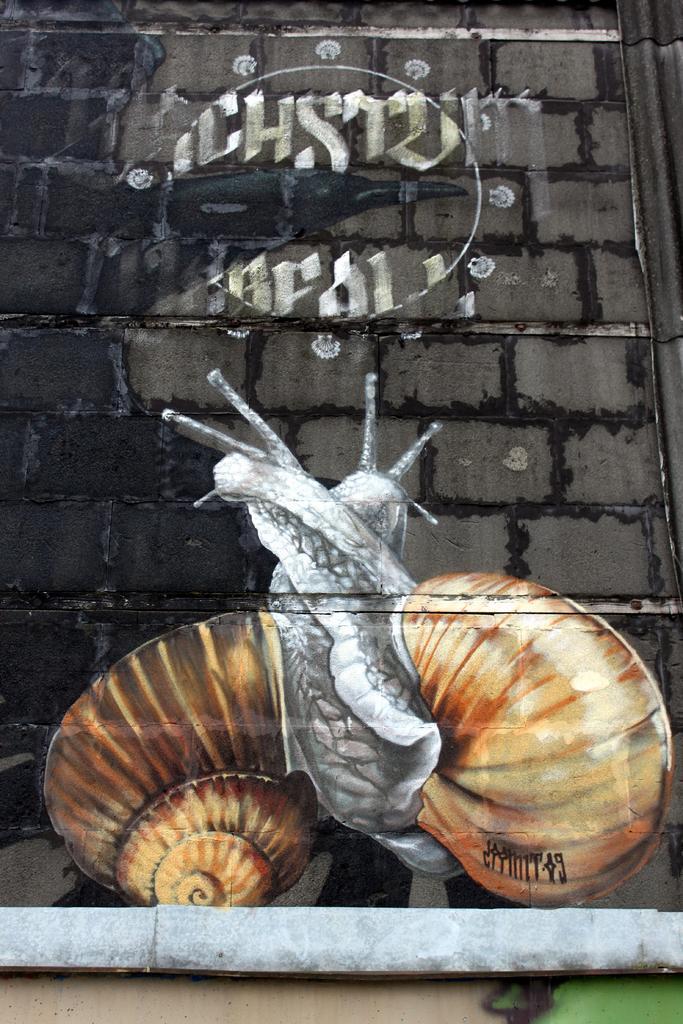Describe this image in one or two sentences. In the image we can see a wall and painting on it. On the wall there is a painting of a snail, this is a pipe. 